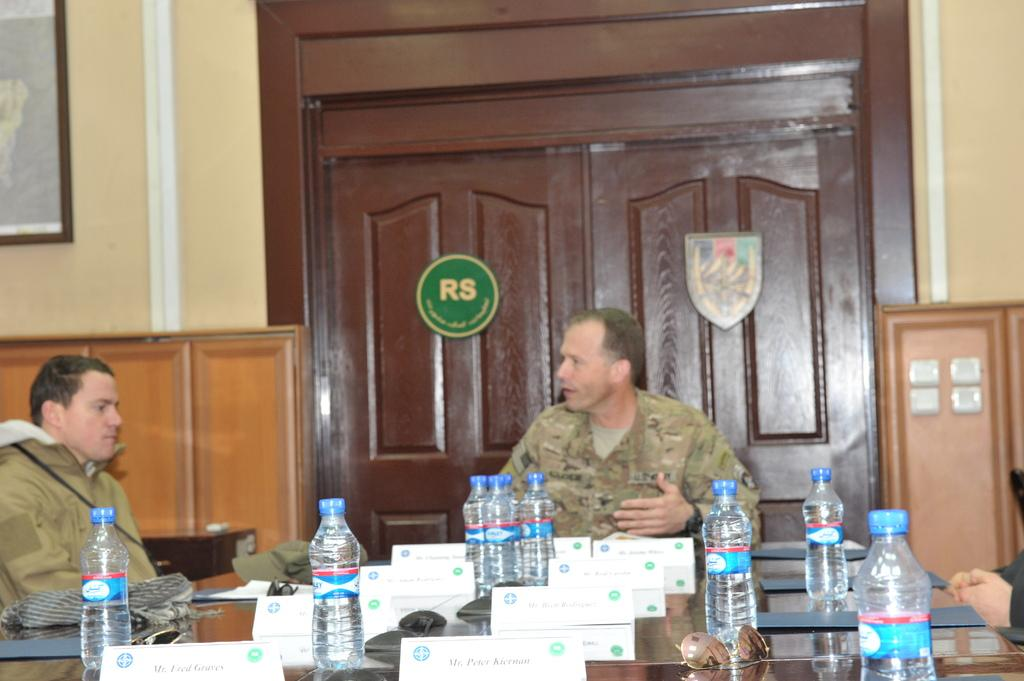<image>
Summarize the visual content of the image. Troops from the Resolute Support Meeting (RS) have a meeting. 